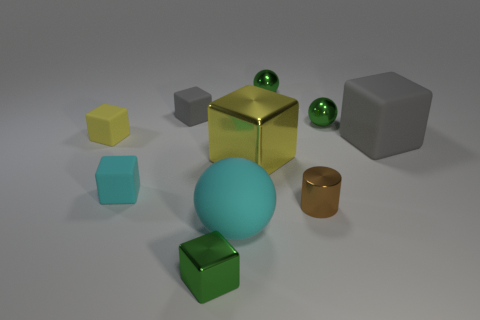Does the tiny thing that is in front of the tiny brown thing have the same material as the small green ball right of the brown object?
Your answer should be compact. Yes. How many things are brown rubber blocks or spheres that are behind the cylinder?
Provide a succinct answer. 2. There is a small rubber thing that is the same color as the rubber ball; what is its shape?
Provide a short and direct response. Cube. What material is the small yellow block?
Keep it short and to the point. Rubber. Do the small brown thing and the small cyan thing have the same material?
Provide a succinct answer. No. How many matte objects are either large yellow cubes or small red cubes?
Ensure brevity in your answer.  0. What is the shape of the cyan rubber thing in front of the tiny metal cylinder?
Ensure brevity in your answer.  Sphere. There is a green block that is made of the same material as the brown thing; what size is it?
Keep it short and to the point. Small. There is a large object that is both on the left side of the large matte block and behind the big cyan sphere; what is its shape?
Offer a very short reply. Cube. There is a matte block in front of the big gray block; does it have the same color as the large ball?
Keep it short and to the point. Yes. 